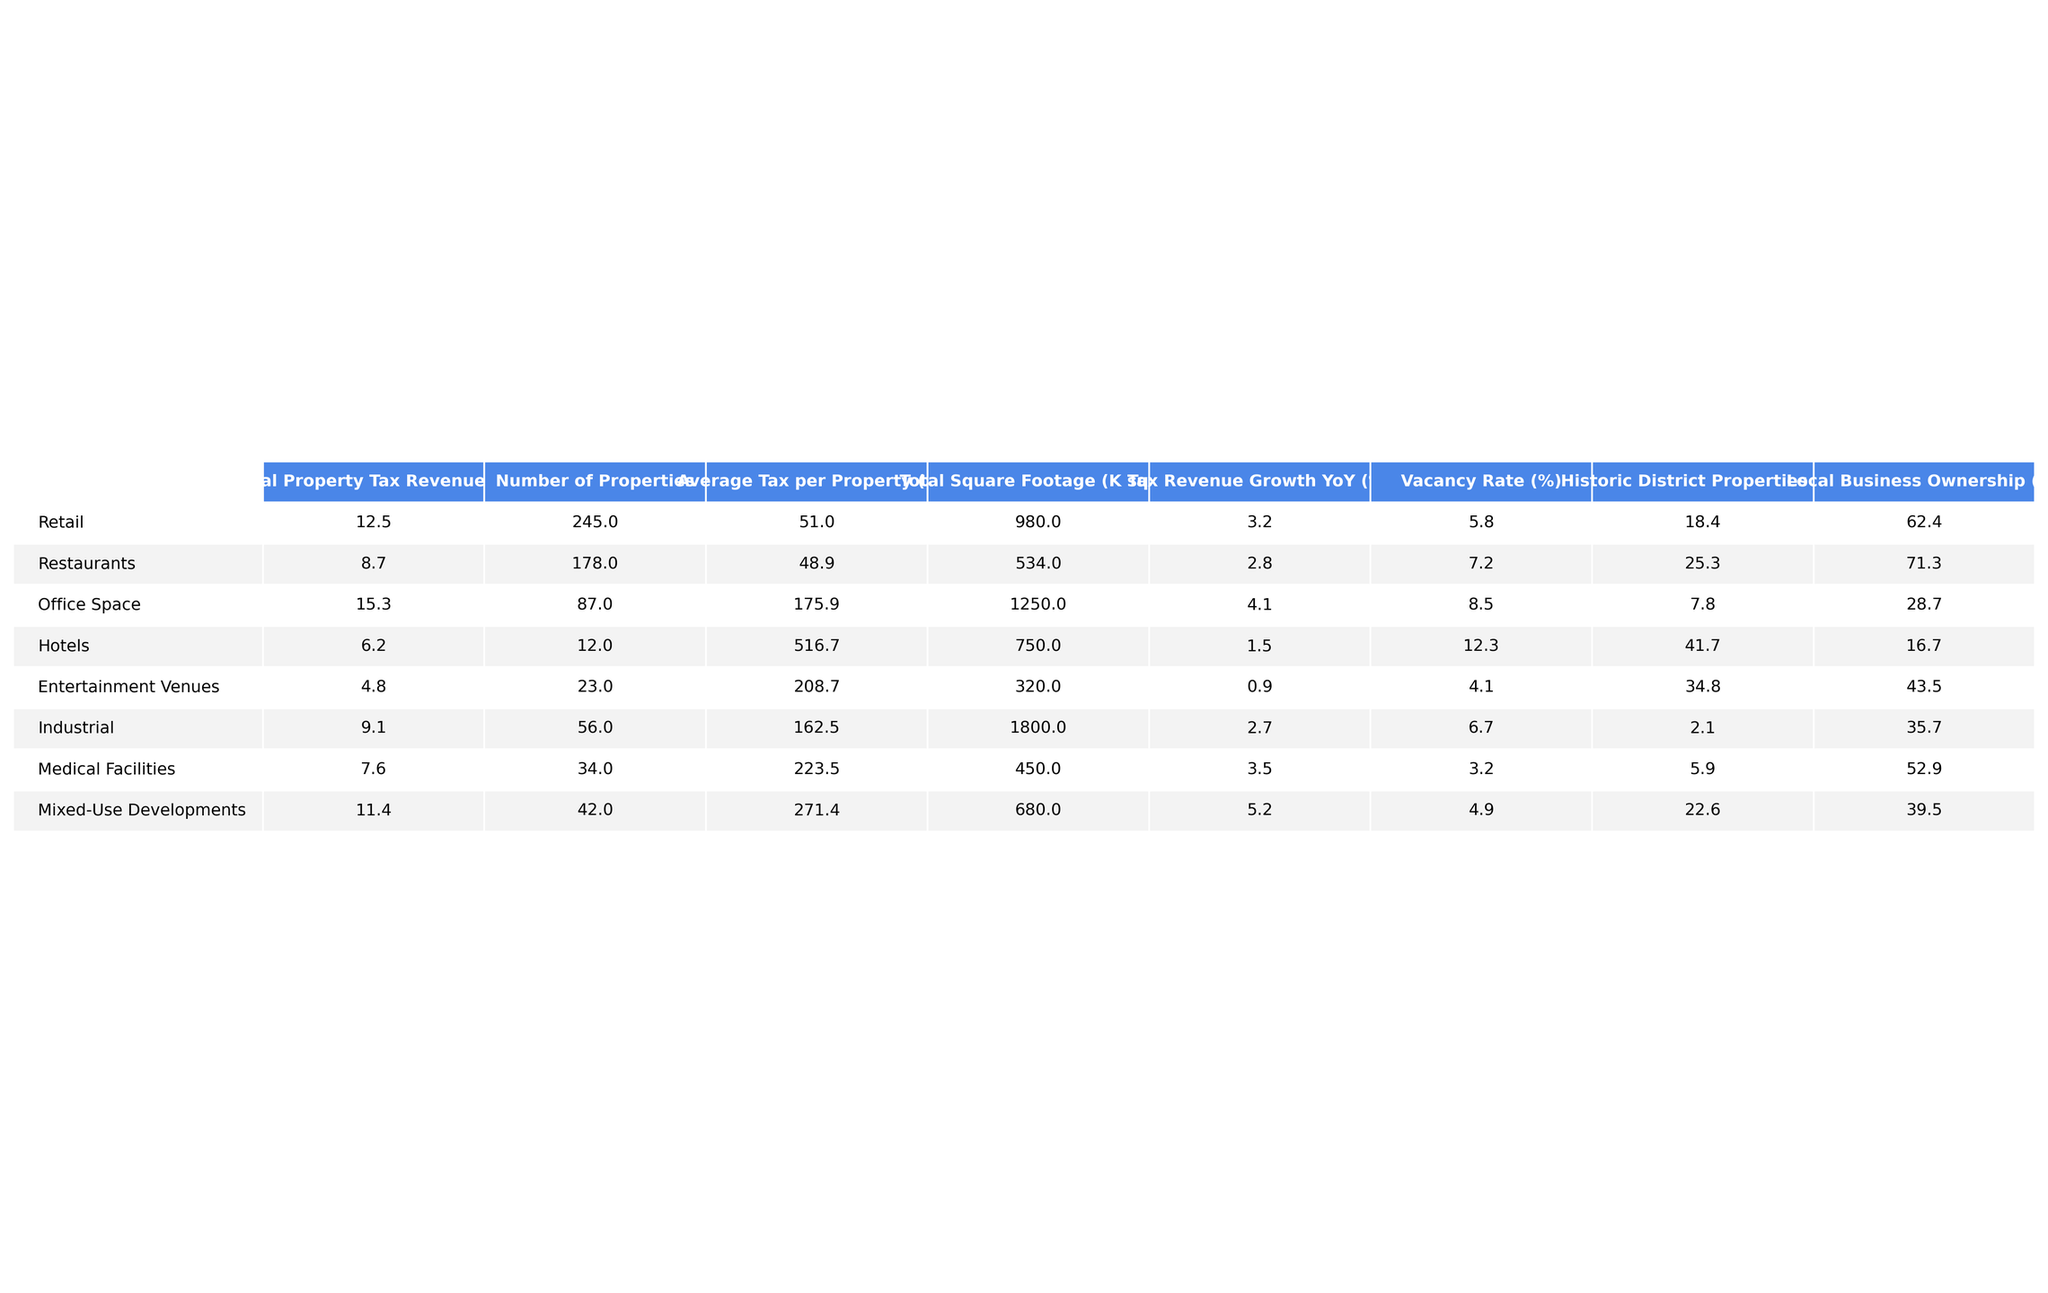What is the annual property tax revenue for retail businesses? The table lists the annual property tax revenue for retail businesses as $12.5 million.
Answer: 12.5 Which business category has the highest average tax per property? The average tax per property for office space is $175.9K, which is higher than all other categories listed.
Answer: Office Space What is the total annual property tax revenue from entertainment venues and hotels combined? Adding the revenues from entertainment venues ($4.8M) and hotels ($6.2M) gives a total of $11.0 million ($4.8M + $6.2M = $11.0M).
Answer: 11.0 What is the percentage of local business ownership in the hotel category? The table states that local business ownership for hotels is 16.7%.
Answer: 16.7 What is the average property tax revenue for medical facilities compared to the industrial category? The average tax per property for medical facilities is $223.5K and for industrial properties is $162.5K. Comparing these, medical facilities have a higher average tax revenue per property.
Answer: Medical Facilities have a higher average Are there more properties in retail or in mixed-use developments? There are 245 retail properties compared to 42 mixed-use developments, indicating retail has more properties.
Answer: Retail What is the average property tax revenue growth for restaurants compared to the overall average growth? The average tax revenue growth for restaurants is 2.8%. By averaging all categories' growth, we find the overall average is (3.2 + 2.8 + 4.1 + 1.5 + 0.9 + 2.7 + 3.5 + 5.2) / 8 = approximately 2.7%. Since 2.8% is higher than 2.7%, restaurants exceed the overall average growth percentage.
Answer: Restaurants exceed the average How does the vacancy rate of office space compare to that of entertainment venues? The vacancy rate for office space is 8.5%, while for entertainment venues it is 4.1%. Thus, office space has a higher vacancy rate than entertainment venues.
Answer: Higher for Office Space What percentage of properties in the industrial category are in a historic district? The table shows that only 2.1% of industrial properties are in a historic district.
Answer: 2.1 Combining the total square footage of hotels and entertainment venues, what would that amount to? The total square footage for hotels is 750K sq ft and for entertainment venues is 320K sq ft. Adding these gives us a total of 1070K sq ft (750 + 320 = 1070).
Answer: 1070K sq ft 